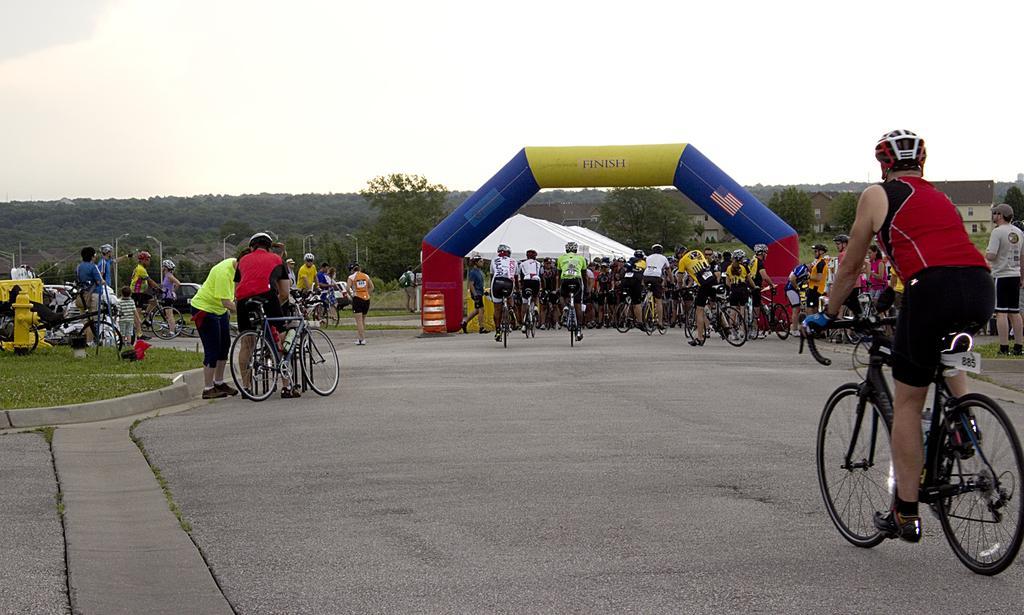Could you give a brief overview of what you see in this image? There is a road. There are many people wearing helmets are riding cycles. There is an arch. In the background there are trees and sky. Also there are many people. 